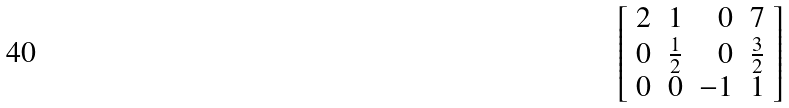Convert formula to latex. <formula><loc_0><loc_0><loc_500><loc_500>\left [ { \begin{array} { r r r r } { 2 } & { 1 } & { 0 } & { 7 } \\ { 0 } & { { \frac { 1 } { 2 } } } & { 0 } & { { \frac { 3 } { 2 } } } \\ { 0 } & { 0 } & { - 1 } & { 1 } \end{array} } \right ]</formula> 